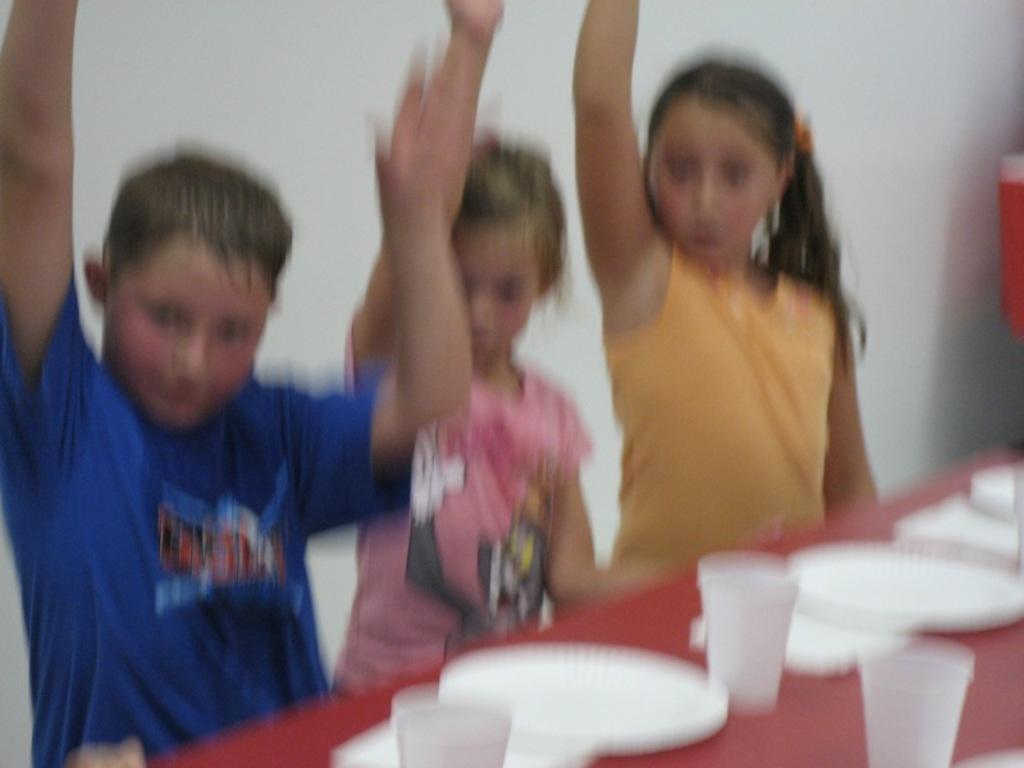Describe this image in one or two sentences. In this picture there are group of people standing behind the table. There are plates, glasses on the table. At the back there is a wall and there is an object. 